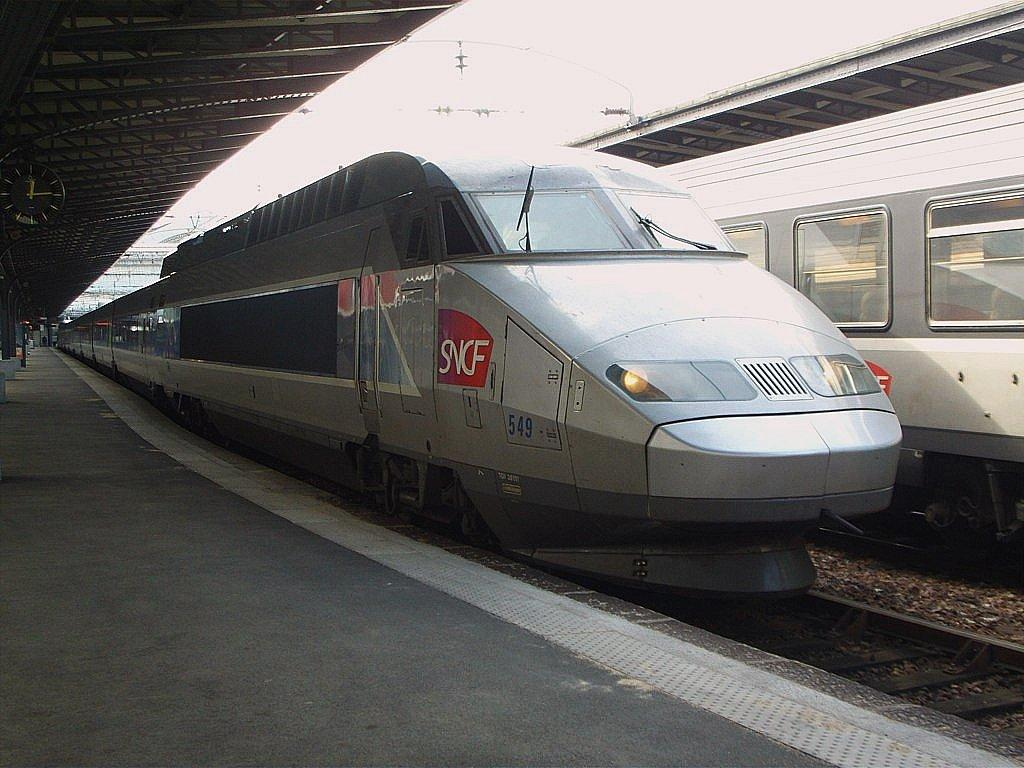<image>
Present a compact description of the photo's key features. Silver train with the number 549 on the side parked. 